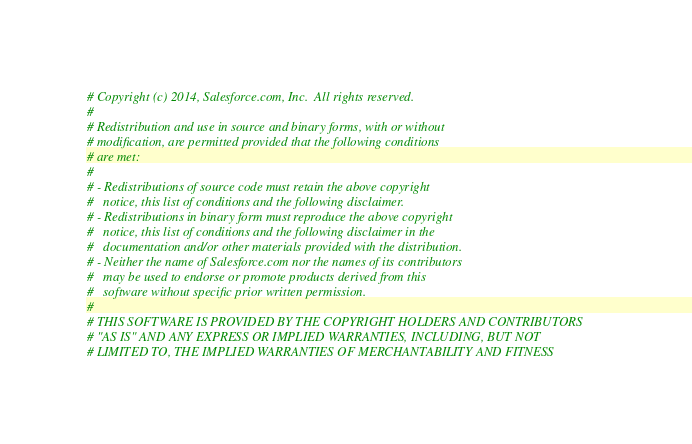Convert code to text. <code><loc_0><loc_0><loc_500><loc_500><_Cython_># Copyright (c) 2014, Salesforce.com, Inc.  All rights reserved.
#
# Redistribution and use in source and binary forms, with or without
# modification, are permitted provided that the following conditions
# are met:
#
# - Redistributions of source code must retain the above copyright
#   notice, this list of conditions and the following disclaimer.
# - Redistributions in binary form must reproduce the above copyright
#   notice, this list of conditions and the following disclaimer in the
#   documentation and/or other materials provided with the distribution.
# - Neither the name of Salesforce.com nor the names of its contributors
#   may be used to endorse or promote products derived from this
#   software without specific prior written permission.
#
# THIS SOFTWARE IS PROVIDED BY THE COPYRIGHT HOLDERS AND CONTRIBUTORS
# "AS IS" AND ANY EXPRESS OR IMPLIED WARRANTIES, INCLUDING, BUT NOT
# LIMITED TO, THE IMPLIED WARRANTIES OF MERCHANTABILITY AND FITNESS</code> 